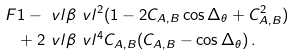<formula> <loc_0><loc_0><loc_500><loc_500>F & 1 - \ v l \beta \ v l ^ { 2 } ( 1 - 2 C _ { A , B } \cos \Delta _ { \theta } + C _ { A , B } ^ { 2 } ) \\ & + 2 \ v l \beta \ v l ^ { 4 } C _ { A , B } ( C _ { A , B } - \cos \Delta _ { \theta } ) \, .</formula> 